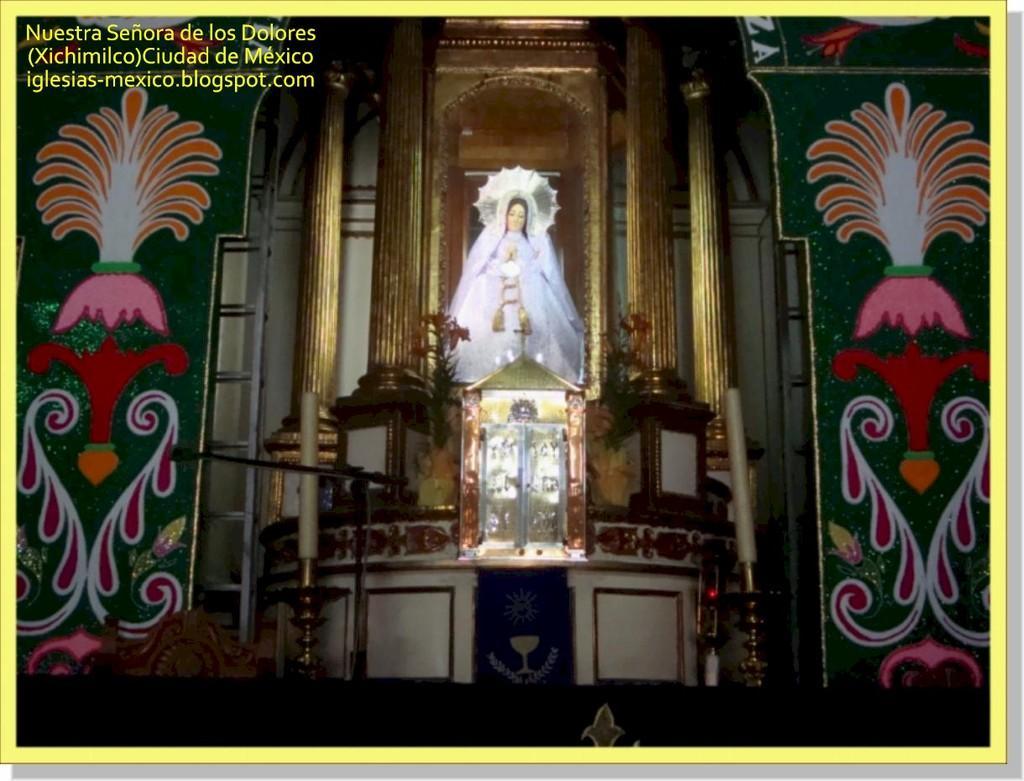How would you summarize this image in a sentence or two? In this image in the center there is a statue. On the right side there is a poster and there is a stand. On the left side there is a poster which is green in colour and there is a stand. In the background there is wall and there is a window and there is some text written on the image. 